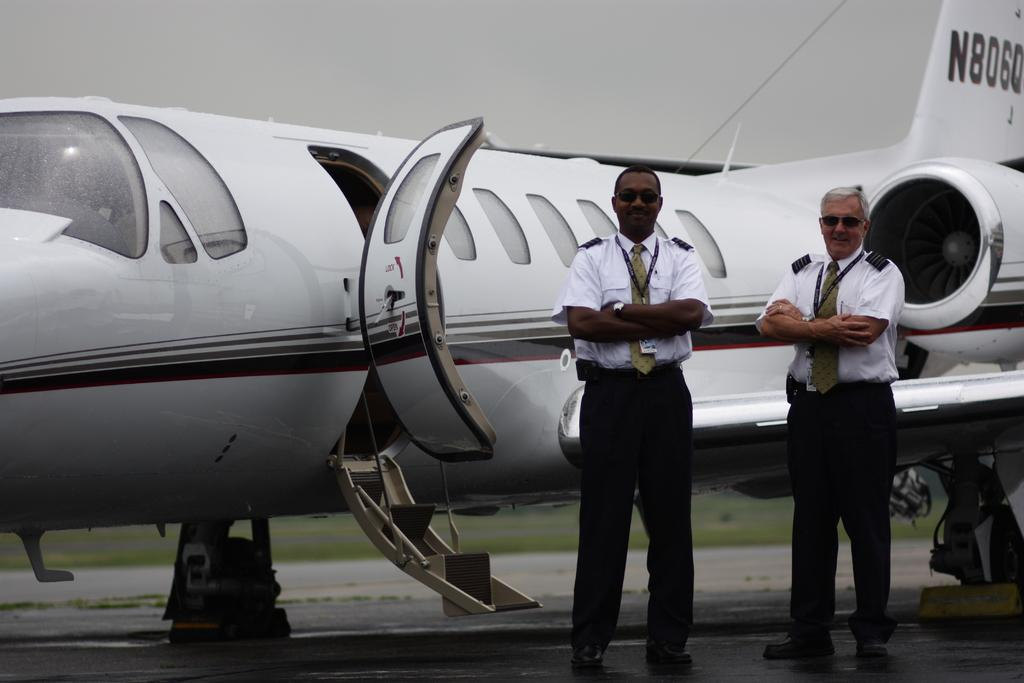How many people are in the foreground of the image? There are two men standing in the foreground of the image. What is the location of the men in the image? The men are standing on the road. What can be seen in the background of the image? There is an airplane and the sky visible in the background of the image. What type of surface is at the bottom of the image? Grass is present at the bottom of the image. What type of wood is used to make the lead in the image? There is no lead or wood present in the image. 